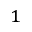Convert formula to latex. <formula><loc_0><loc_0><loc_500><loc_500>^ { 1 }</formula> 